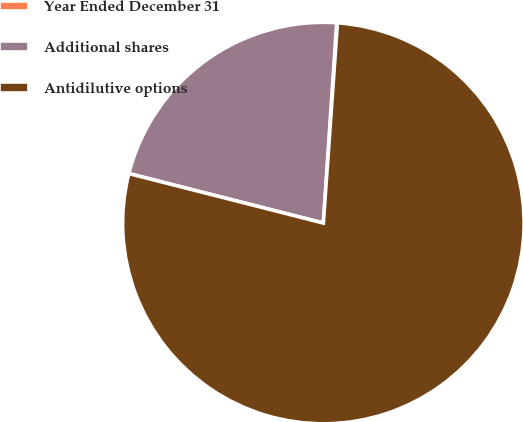Convert chart to OTSL. <chart><loc_0><loc_0><loc_500><loc_500><pie_chart><fcel>Year Ended December 31<fcel>Additional shares<fcel>Antidilutive options<nl><fcel>0.06%<fcel>22.09%<fcel>77.84%<nl></chart> 